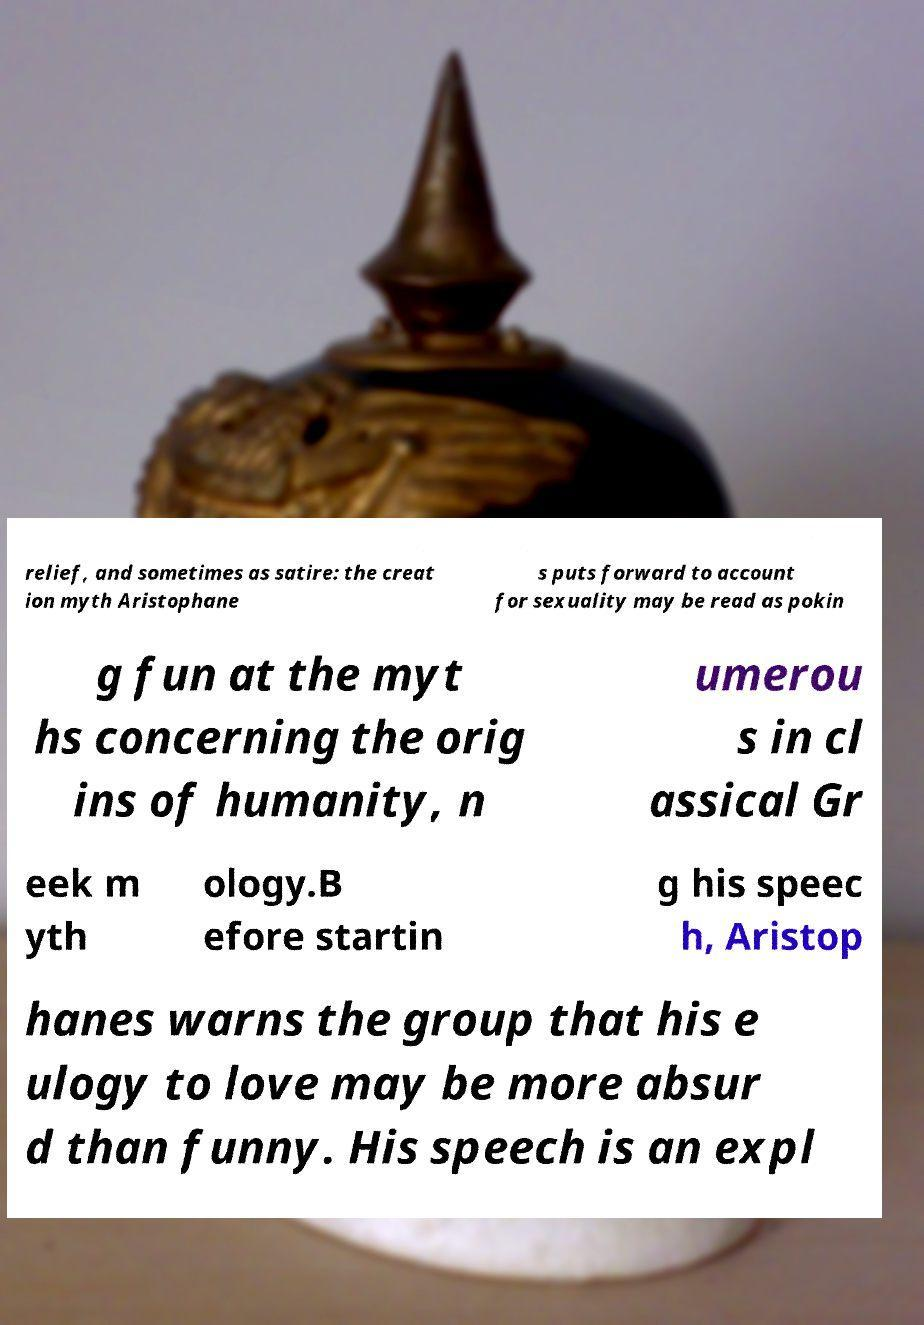Could you assist in decoding the text presented in this image and type it out clearly? relief, and sometimes as satire: the creat ion myth Aristophane s puts forward to account for sexuality may be read as pokin g fun at the myt hs concerning the orig ins of humanity, n umerou s in cl assical Gr eek m yth ology.B efore startin g his speec h, Aristop hanes warns the group that his e ulogy to love may be more absur d than funny. His speech is an expl 